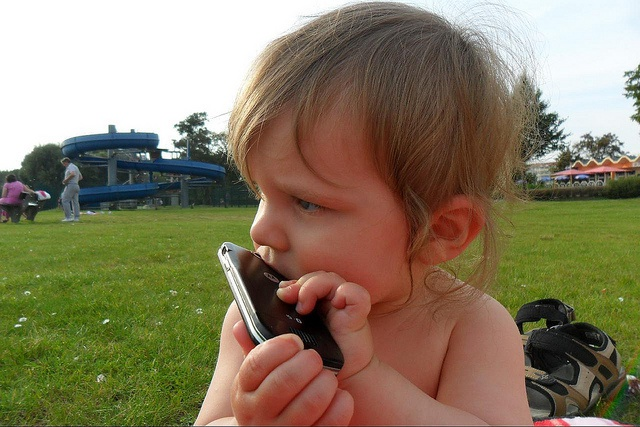Describe the objects in this image and their specific colors. I can see people in white, brown, and maroon tones, cell phone in white, black, darkgray, and maroon tones, people in white, gray, black, darkgray, and blue tones, bench in white, black, gray, and purple tones, and people in white, purple, and black tones in this image. 